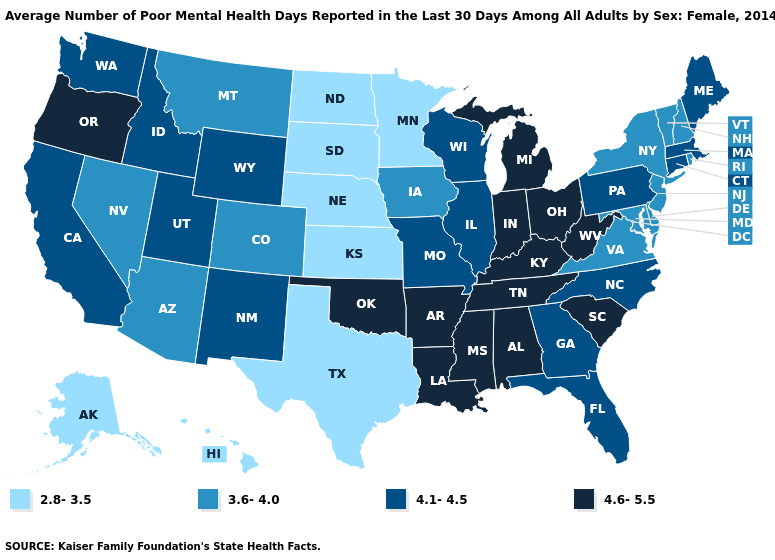Among the states that border Delaware , does Pennsylvania have the highest value?
Short answer required. Yes. What is the value of New Jersey?
Quick response, please. 3.6-4.0. Does Indiana have a lower value than Hawaii?
Write a very short answer. No. Name the states that have a value in the range 4.1-4.5?
Write a very short answer. California, Connecticut, Florida, Georgia, Idaho, Illinois, Maine, Massachusetts, Missouri, New Mexico, North Carolina, Pennsylvania, Utah, Washington, Wisconsin, Wyoming. Which states have the lowest value in the USA?
Answer briefly. Alaska, Hawaii, Kansas, Minnesota, Nebraska, North Dakota, South Dakota, Texas. Name the states that have a value in the range 4.1-4.5?
Be succinct. California, Connecticut, Florida, Georgia, Idaho, Illinois, Maine, Massachusetts, Missouri, New Mexico, North Carolina, Pennsylvania, Utah, Washington, Wisconsin, Wyoming. Does the first symbol in the legend represent the smallest category?
Be succinct. Yes. Name the states that have a value in the range 4.6-5.5?
Give a very brief answer. Alabama, Arkansas, Indiana, Kentucky, Louisiana, Michigan, Mississippi, Ohio, Oklahoma, Oregon, South Carolina, Tennessee, West Virginia. What is the value of Rhode Island?
Concise answer only. 3.6-4.0. What is the value of Delaware?
Quick response, please. 3.6-4.0. Does Connecticut have the lowest value in the Northeast?
Keep it brief. No. Among the states that border Washington , which have the highest value?
Give a very brief answer. Oregon. Does New Mexico have the lowest value in the USA?
Quick response, please. No. What is the value of North Dakota?
Be succinct. 2.8-3.5. Which states have the lowest value in the South?
Answer briefly. Texas. 